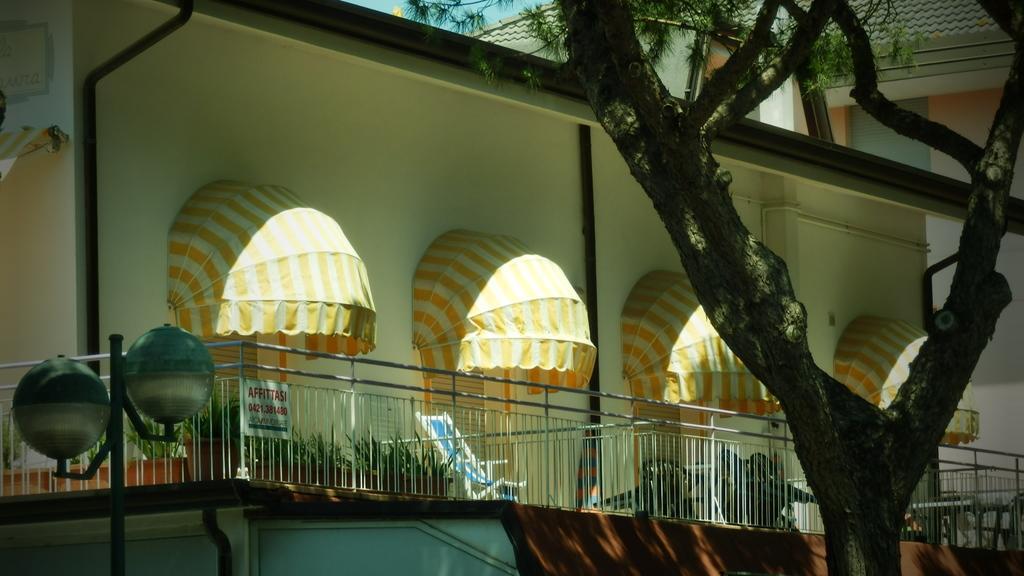Could you give a brief overview of what you see in this image? In this picture we can see the building. On the right there is a tree. At the bottom we can see fencing, plants, pot, table and chairs. In the bottom left there is a street light. At the top there is a sky. 